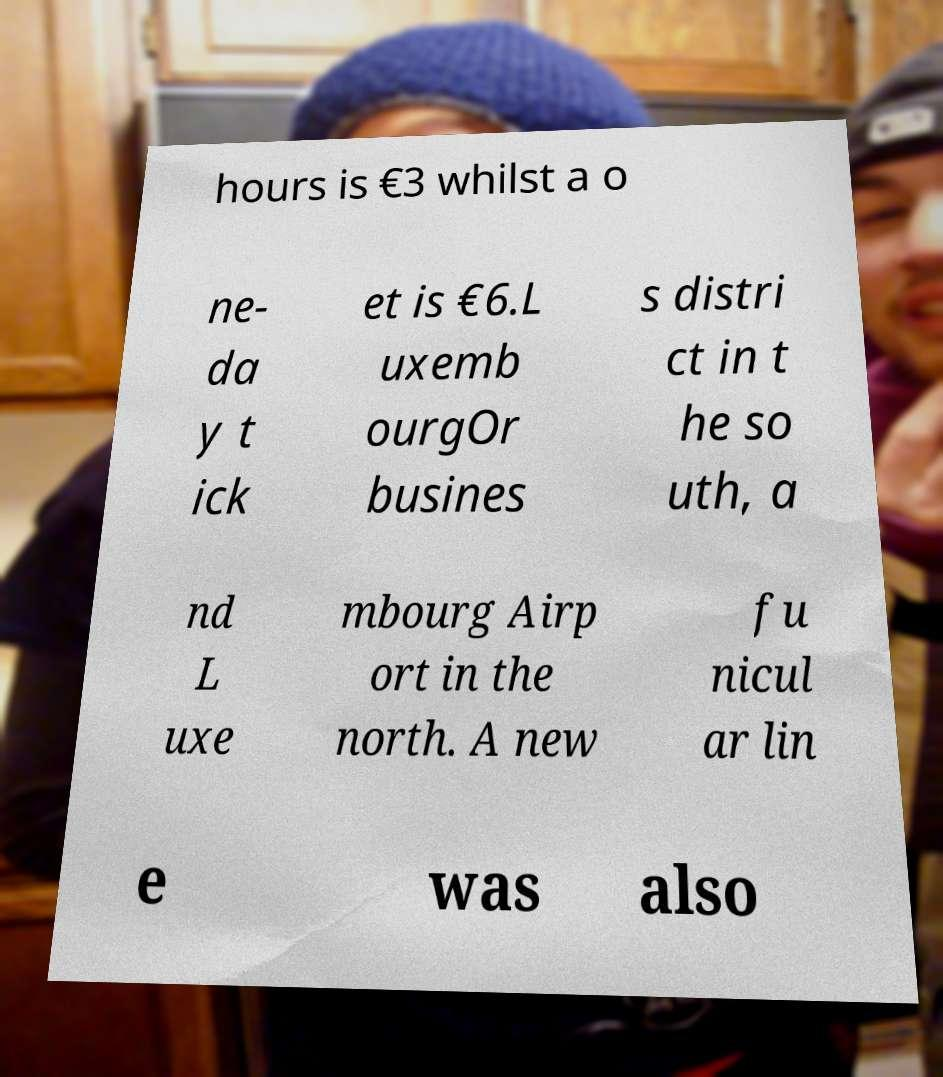What messages or text are displayed in this image? I need them in a readable, typed format. hours is €3 whilst a o ne- da y t ick et is €6.L uxemb ourgOr busines s distri ct in t he so uth, a nd L uxe mbourg Airp ort in the north. A new fu nicul ar lin e was also 